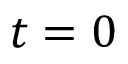<formula> <loc_0><loc_0><loc_500><loc_500>t = 0</formula> 